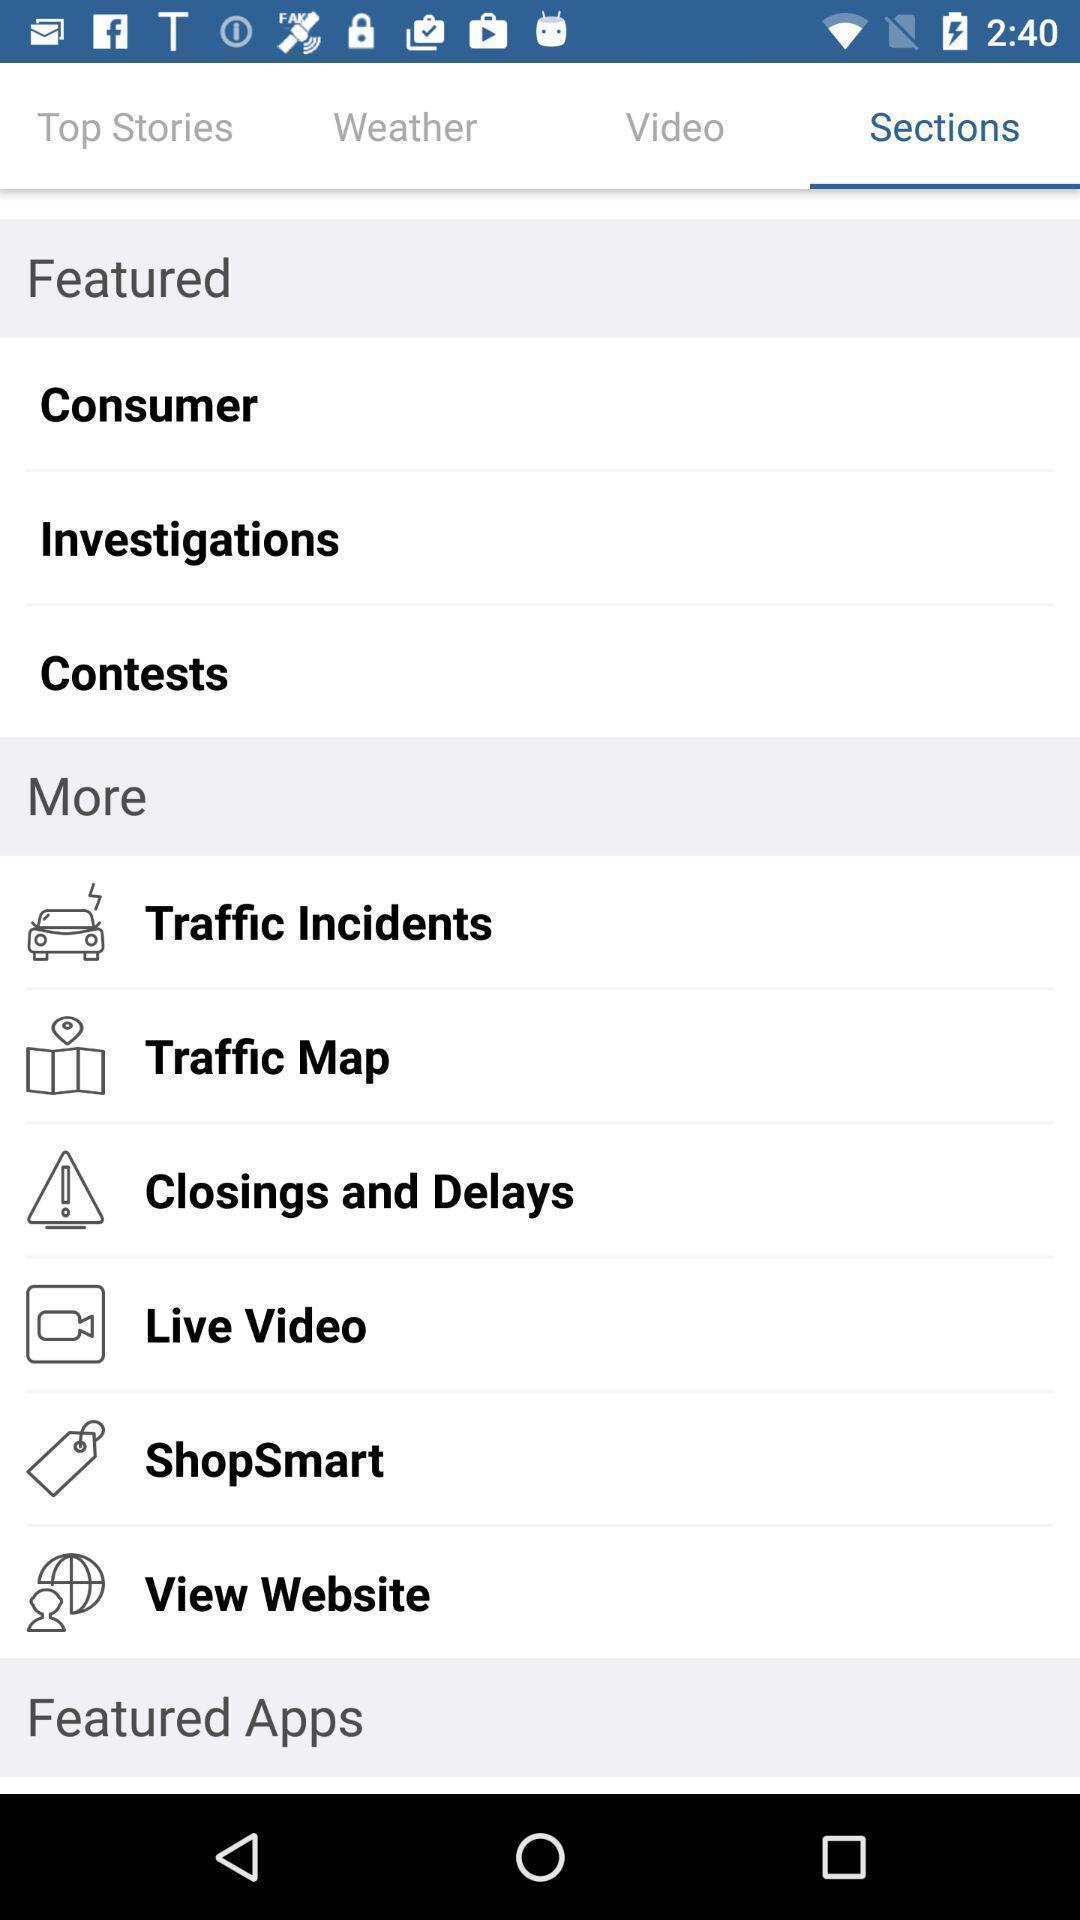Give me a summary of this screen capture. Page showing list of information of social app. 